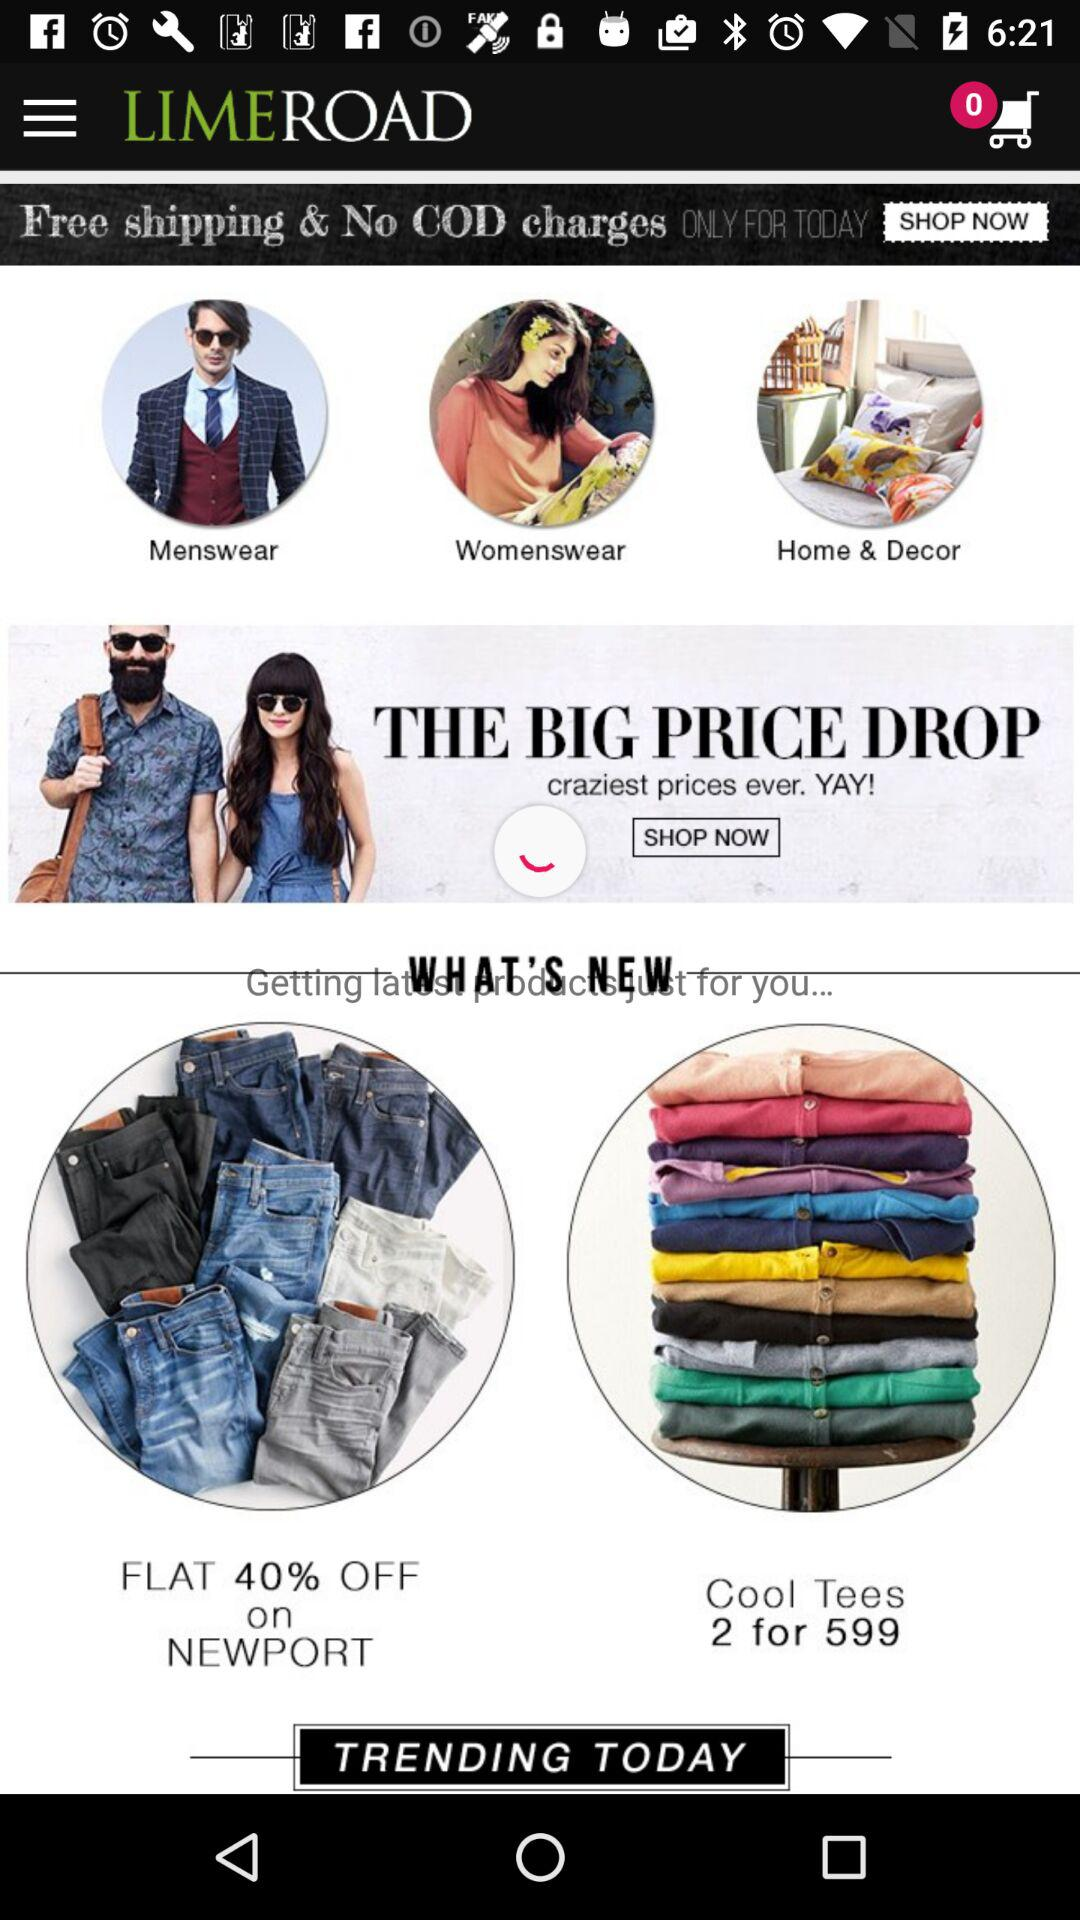How many items are in the cart? There are 0 items in the cart. 